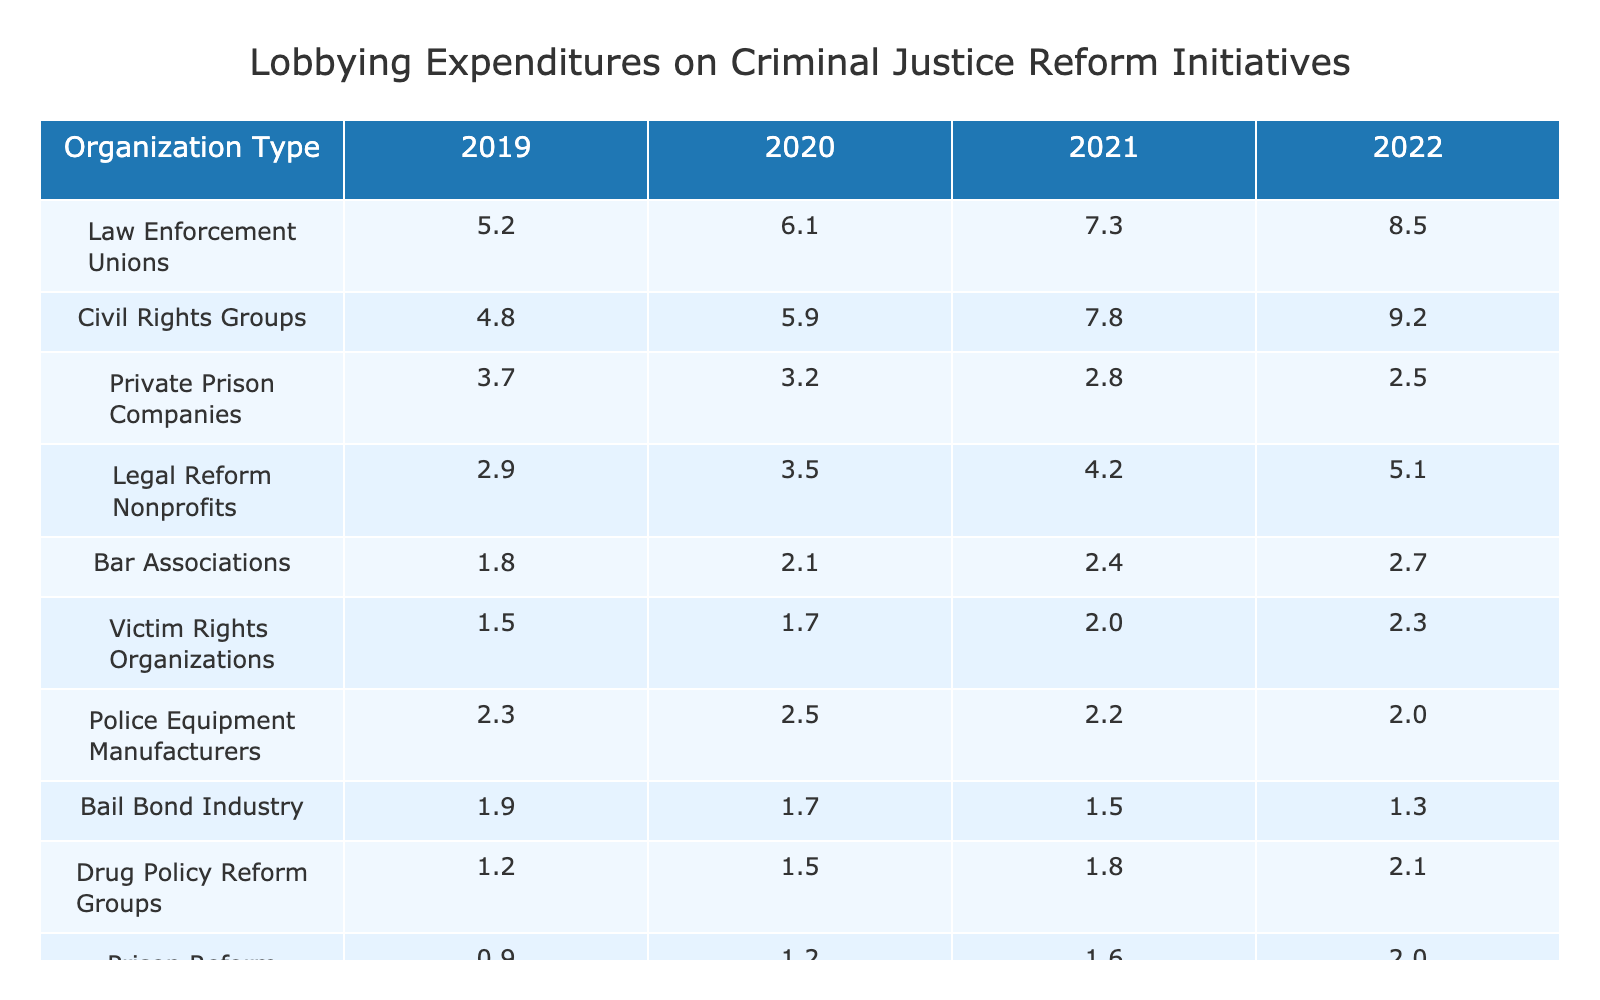What was the total lobbying expenditure by Law Enforcement Unions from 2019 to 2022? To find the total, sum the expenditures for each year: 5.2 + 6.1 + 7.3 + 8.5 = 27.1
Answer: 27.1 Which organization type had the highest lobbying expenditure in 2022? In 2022, Law Enforcement Unions had the highest expenditure at 8.5 compared to all other organization types listed.
Answer: Law Enforcement Unions What is the average lobbying expenditure of Civil Rights Groups over 2019 to 2022? The expenditures are 4.8, 5.9, 7.8, and 9.2. The sum is 4.8 + 5.9 + 7.8 + 9.2 = 27.7, and the average is 27.7 divided by 4, which equals 6.925.
Answer: 6.93 Did the lobbying expenditure of Private Prison Companies increase from 2019 to 2022? The values for Private Prison Companies are 3.7 in 2019 and 2.5 in 2022. Since 2.5 is less than 3.7, the expenditure decreased over this period.
Answer: No What was the percentage change in lobbying expenditure for Legal Reform Nonprofits from 2021 to 2022? The expenditure increased from 4.2 in 2021 to 5.1 in 2022. The change is 5.1 - 4.2 = 0.9. To find the percentage change: (0.9 / 4.2) * 100 = 21.43%.
Answer: 21.43% Which two organization types had the lowest expenditures in 2022, and what were their values? The two lowest expenditures in 2022 are from the Bail Bond Industry at 1.3 and Prison Reform Advocates at 2.0.
Answer: Bail Bond Industry 1.3, Prison Reform Advocates 2.0 How much more did Civil Rights Groups spend compared to Drug Policy Reform Groups in 2022? Civil Rights Groups spent 9.2 in 2022 and Drug Policy Reform Groups spent 2.1. The difference is 9.2 - 2.1 = 7.1.
Answer: 7.1 What trend can be observed in the expenditures of Police Equipment Manufacturers from 2019 to 2022? The expenditures were 2.3 in 2019, 2.5 in 2020, 2.2 in 2021, and 2.0 in 2022. This shows an initial increase followed by a decrease, indicating a downward trend.
Answer: Downward trend Which organization type had consistent growth in expenditures each year from 2019 to 2022? The only organization type with consistent growth is Civil Rights Groups, increasing from 4.8 to 9.2 over the years.
Answer: Civil Rights Groups What is the total lobbying expenditure by all organization types in 2020? Calculate the total by adding all expenditures for 2020: 6.1 + 5.9 + 3.2 + 3.5 + 2.1 + 1.7 + 2.5 + 1.7 + 1.5 + 1.2 = 27.0.
Answer: 27.0 